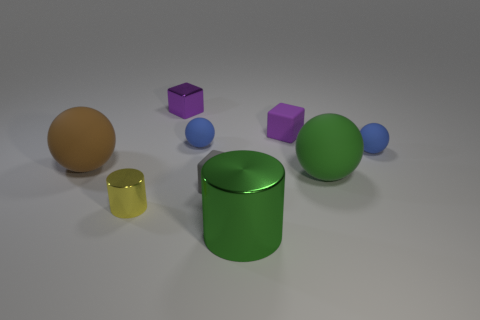Subtract all green spheres. How many purple blocks are left? 2 Subtract all small metallic blocks. How many blocks are left? 2 Subtract all brown balls. How many balls are left? 3 Add 1 matte spheres. How many objects exist? 10 Subtract 1 cylinders. How many cylinders are left? 1 Subtract all cylinders. How many objects are left? 7 Subtract all blue blocks. Subtract all green cylinders. How many blocks are left? 3 Subtract all tiny metallic cylinders. Subtract all large brown rubber things. How many objects are left? 7 Add 3 large shiny objects. How many large shiny objects are left? 4 Add 2 green cylinders. How many green cylinders exist? 3 